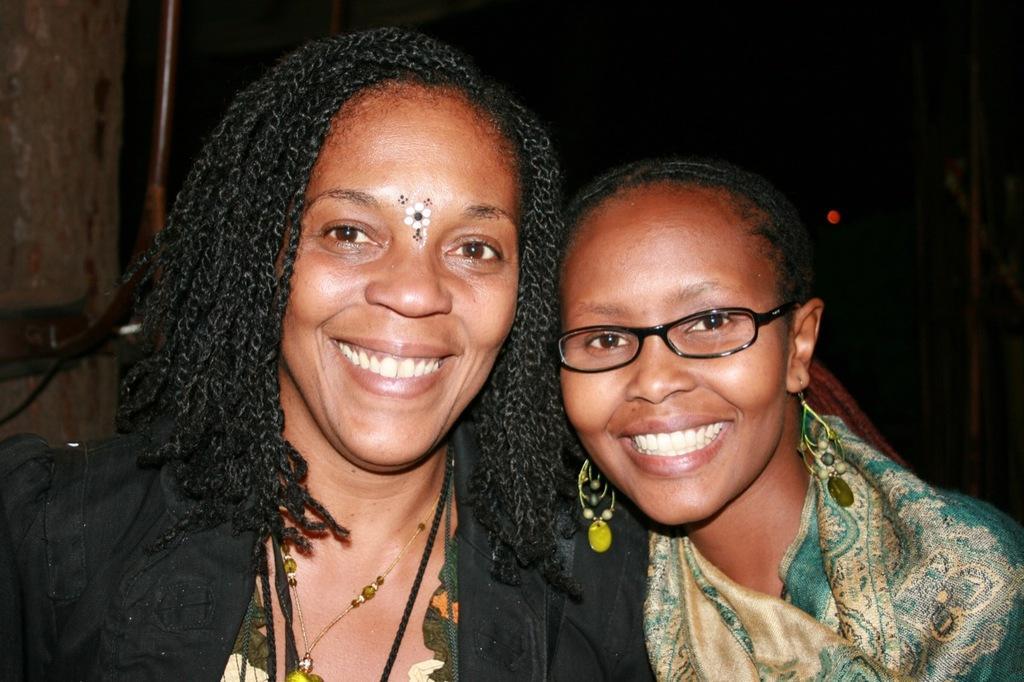How would you summarize this image in a sentence or two? In this picture we can see two women where a woman wore a spectacle and they are smiling and in the background it is dark. 